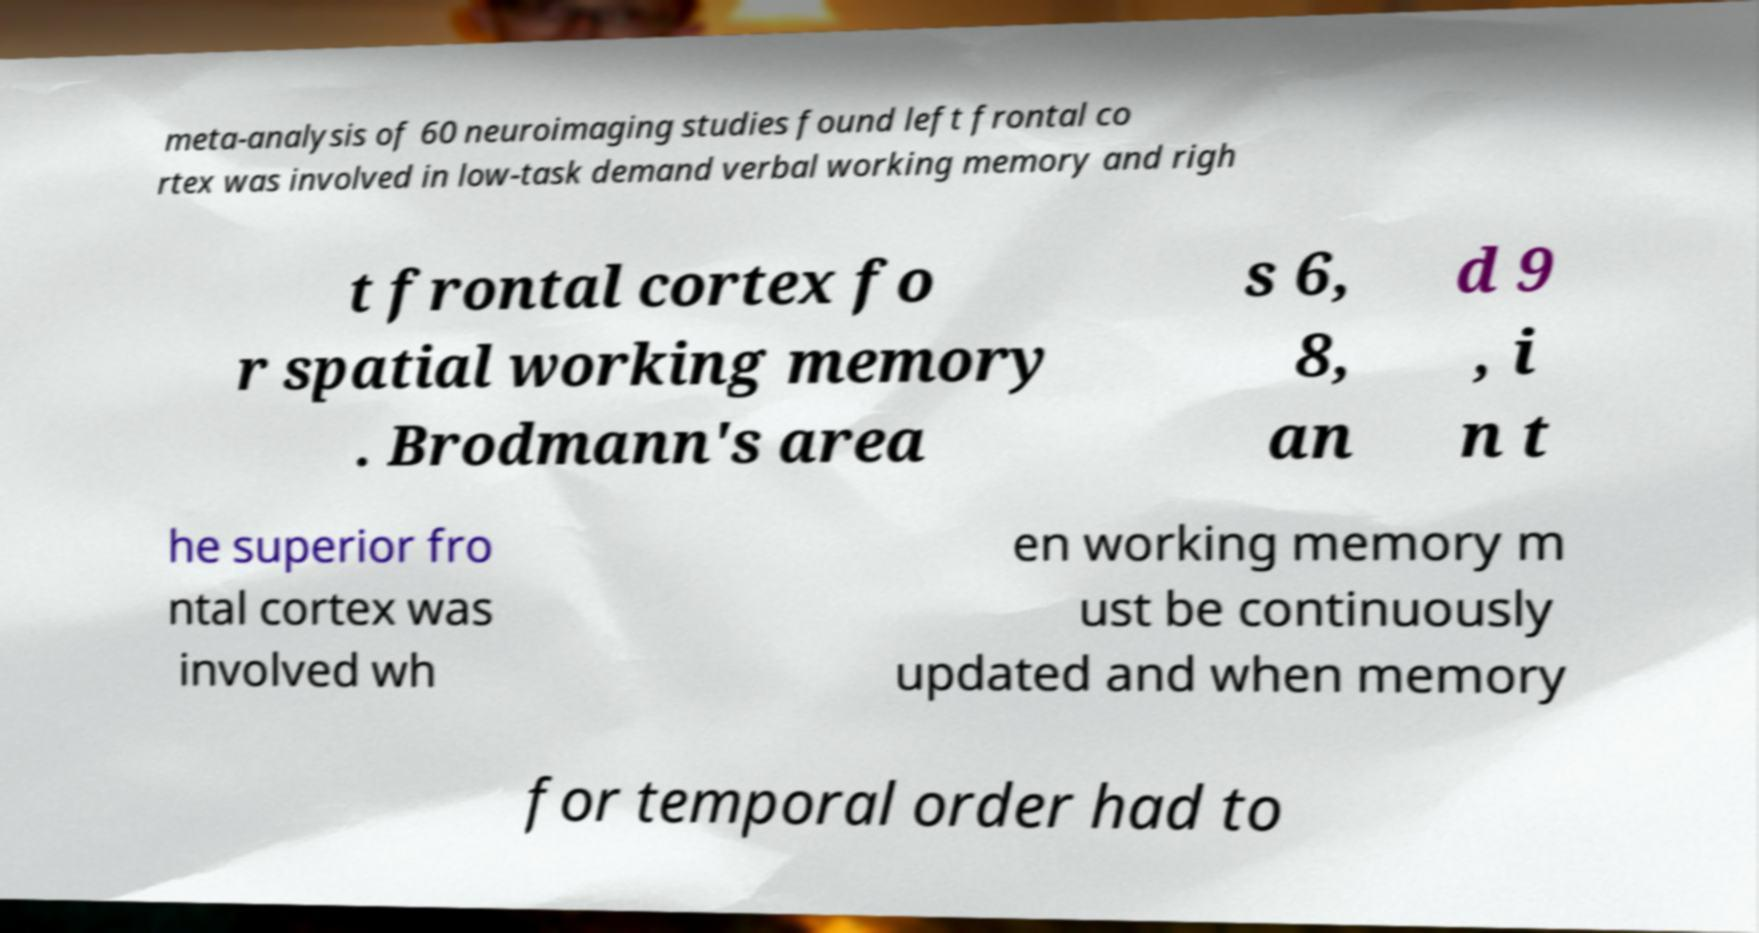Can you accurately transcribe the text from the provided image for me? meta-analysis of 60 neuroimaging studies found left frontal co rtex was involved in low-task demand verbal working memory and righ t frontal cortex fo r spatial working memory . Brodmann's area s 6, 8, an d 9 , i n t he superior fro ntal cortex was involved wh en working memory m ust be continuously updated and when memory for temporal order had to 